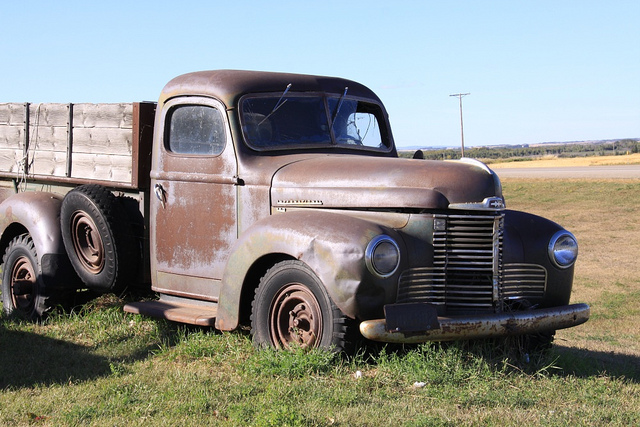<image>How long has the truck been there? It is ambiguous to conclude how long the truck has been there. How long has the truck been there? It is unanswerable how long the truck has been there. 